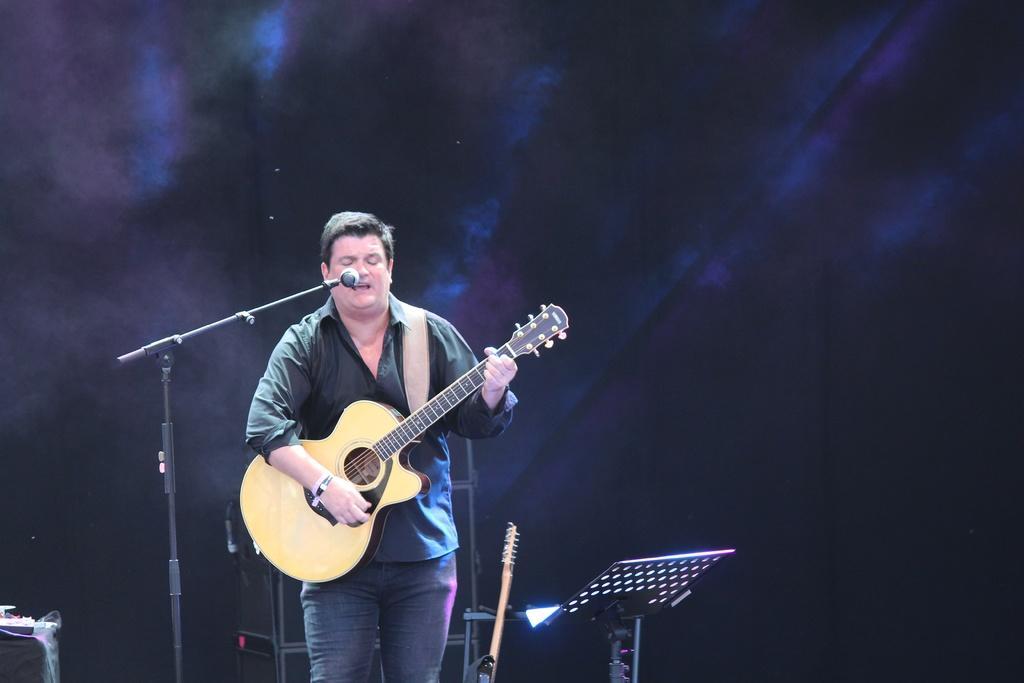Could you give a brief overview of what you see in this image? This is a picture of a man in black shirt holding a guitar and singing a song in front of the man there is a microphone with stand. Behind the man there are some music instruments. Background of the man is in black color. 